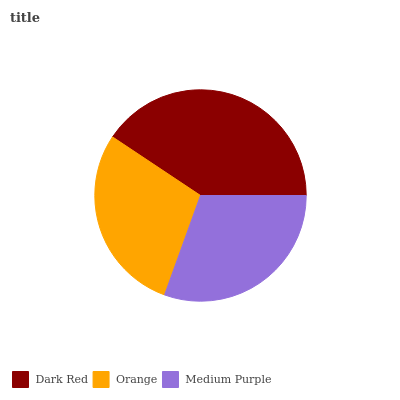Is Orange the minimum?
Answer yes or no. Yes. Is Dark Red the maximum?
Answer yes or no. Yes. Is Medium Purple the minimum?
Answer yes or no. No. Is Medium Purple the maximum?
Answer yes or no. No. Is Medium Purple greater than Orange?
Answer yes or no. Yes. Is Orange less than Medium Purple?
Answer yes or no. Yes. Is Orange greater than Medium Purple?
Answer yes or no. No. Is Medium Purple less than Orange?
Answer yes or no. No. Is Medium Purple the high median?
Answer yes or no. Yes. Is Medium Purple the low median?
Answer yes or no. Yes. Is Orange the high median?
Answer yes or no. No. Is Dark Red the low median?
Answer yes or no. No. 